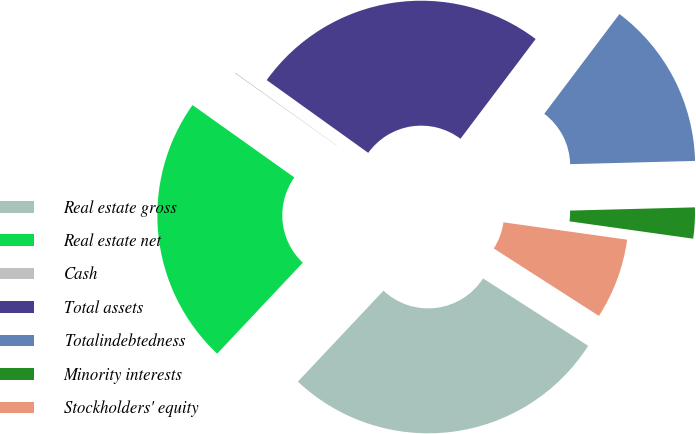Convert chart. <chart><loc_0><loc_0><loc_500><loc_500><pie_chart><fcel>Real estate gross<fcel>Real estate net<fcel>Cash<fcel>Total assets<fcel>Totalindebtedness<fcel>Minority interests<fcel>Stockholders' equity<nl><fcel>27.94%<fcel>22.82%<fcel>0.06%<fcel>25.38%<fcel>14.31%<fcel>2.63%<fcel>6.86%<nl></chart> 